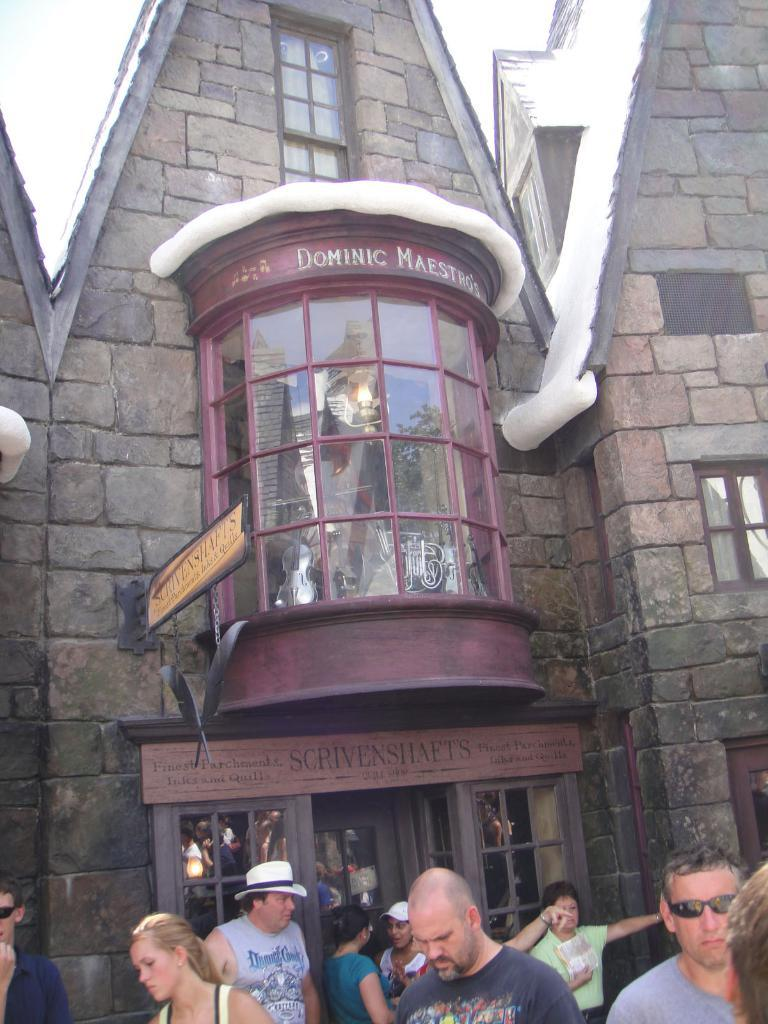What is the main subject in the center of the image? There is a building in the center of the image. Can you describe the people at the bottom side of the image? There are people at the bottom side of the image, but their specific actions or characteristics are not mentioned in the provided facts. How many units of slaves are visible in the image? There is no mention of slaves or any related objects in the image, so it is not possible to answer this question. 